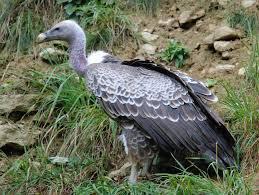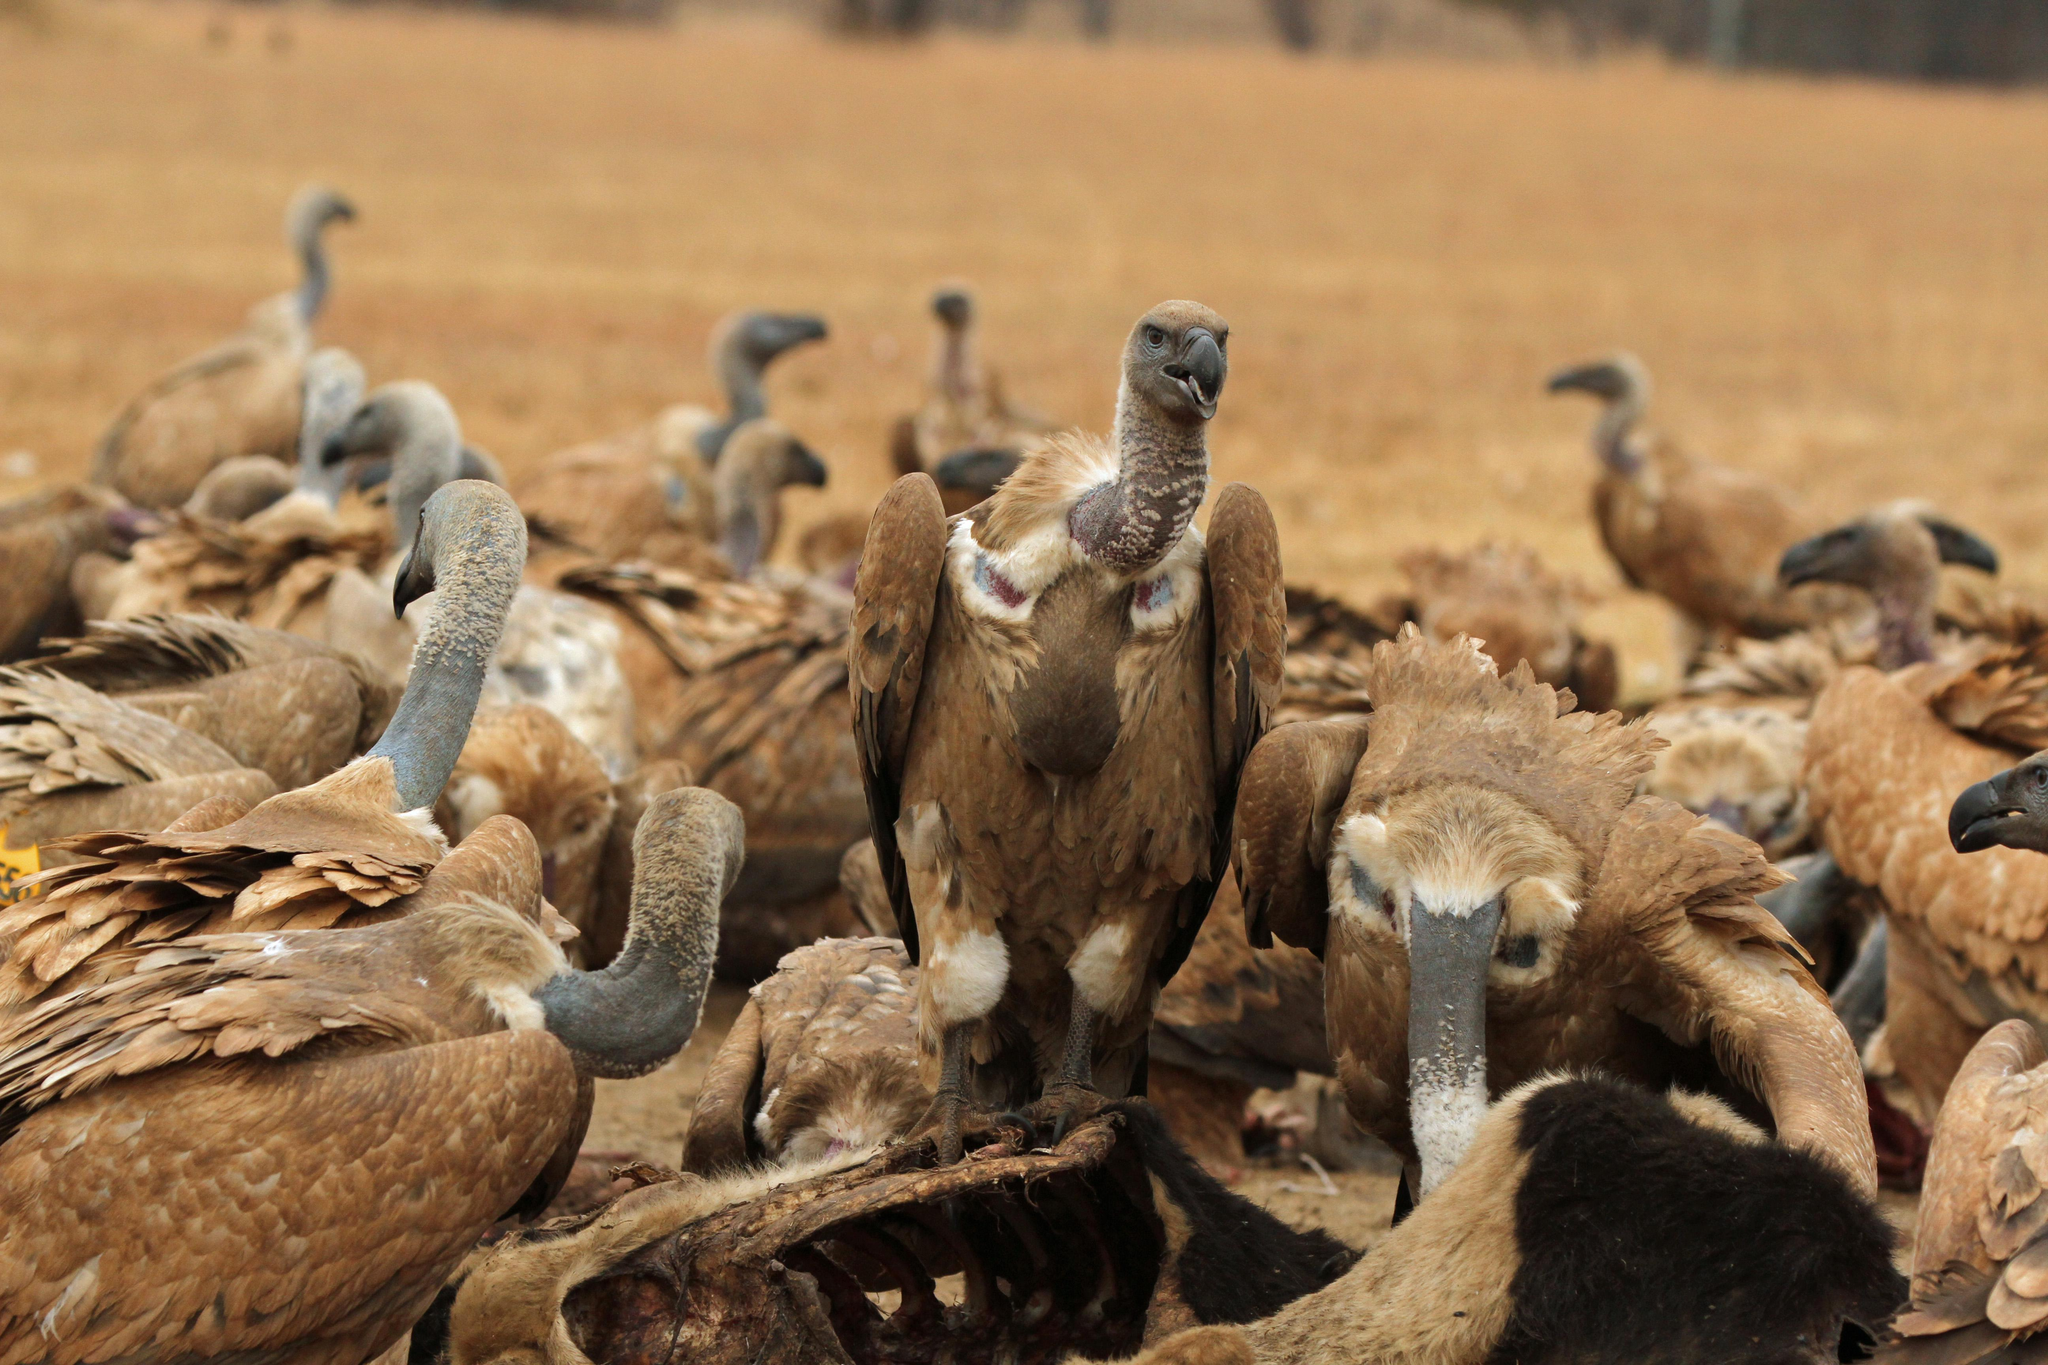The first image is the image on the left, the second image is the image on the right. Analyze the images presented: Is the assertion "There is exactly one bird in one of the images." valid? Answer yes or no. Yes. 